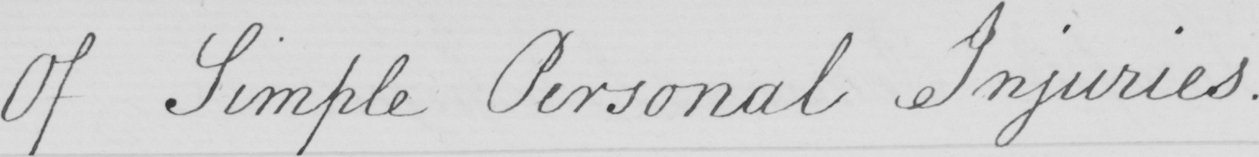Please provide the text content of this handwritten line. Of Simple Personal Injuries . 